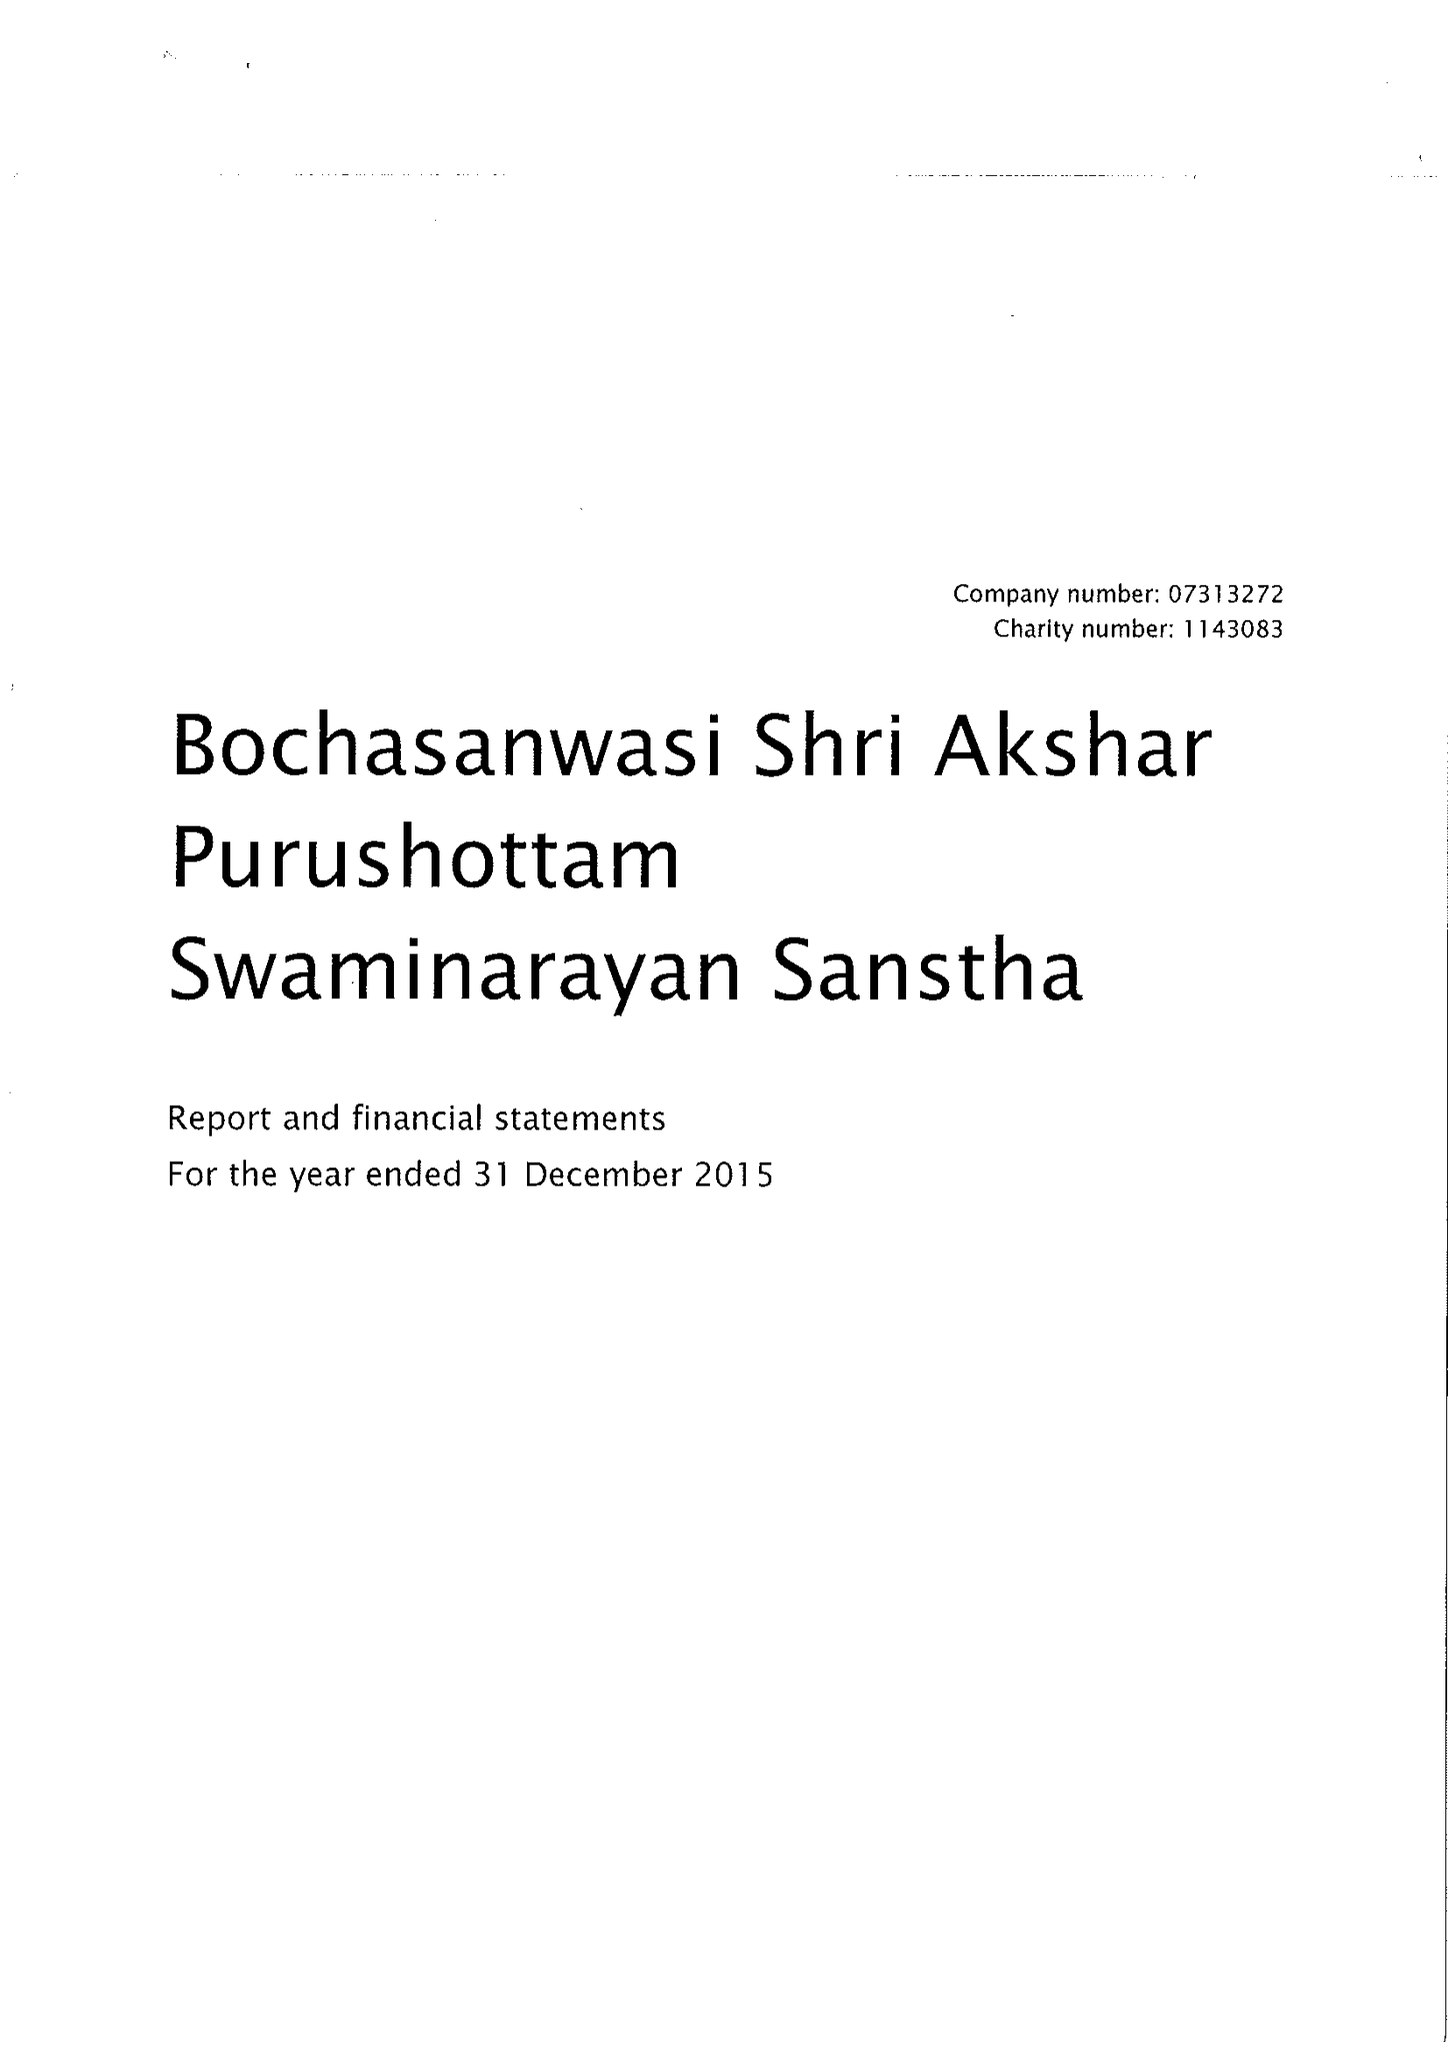What is the value for the address__street_line?
Answer the question using a single word or phrase. 105-119 BRENTFIELD ROAD 